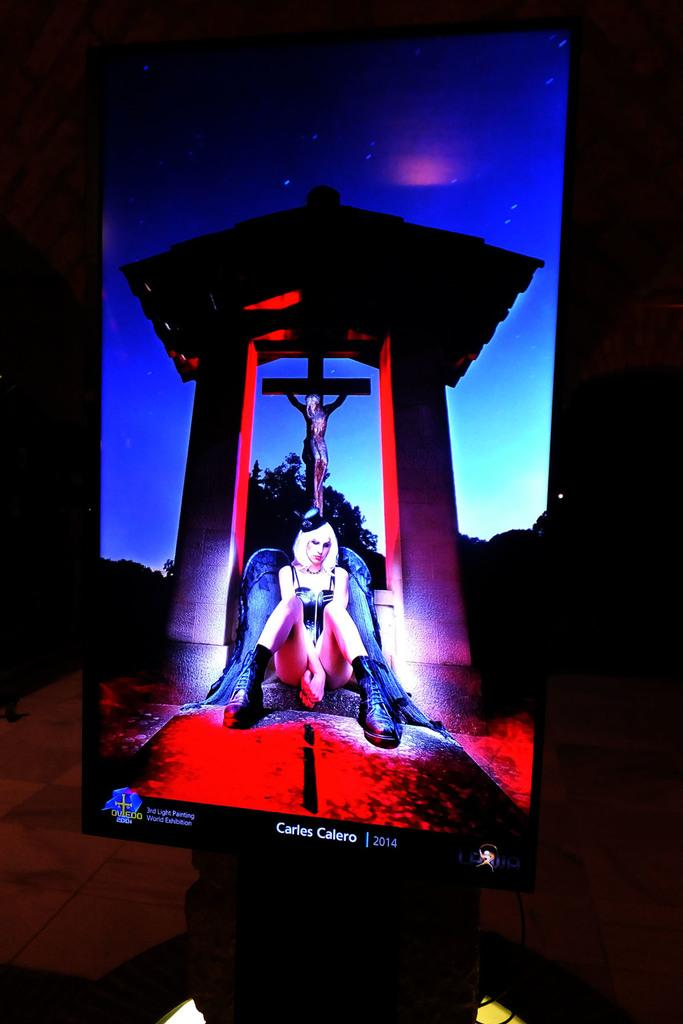What is the main object in the image? There is a screen in the image. What is happening on the screen? A woman is sitting on the screen. What can be seen in the background of the image? There is a cross and trees in the background of the image. Where is the image set? The image is set in a room. What is visible at the bottom of the image? There is a floor visible at the bottom of the image. What type of steel is being used by the woman in the image? There is no steel present in the image. 